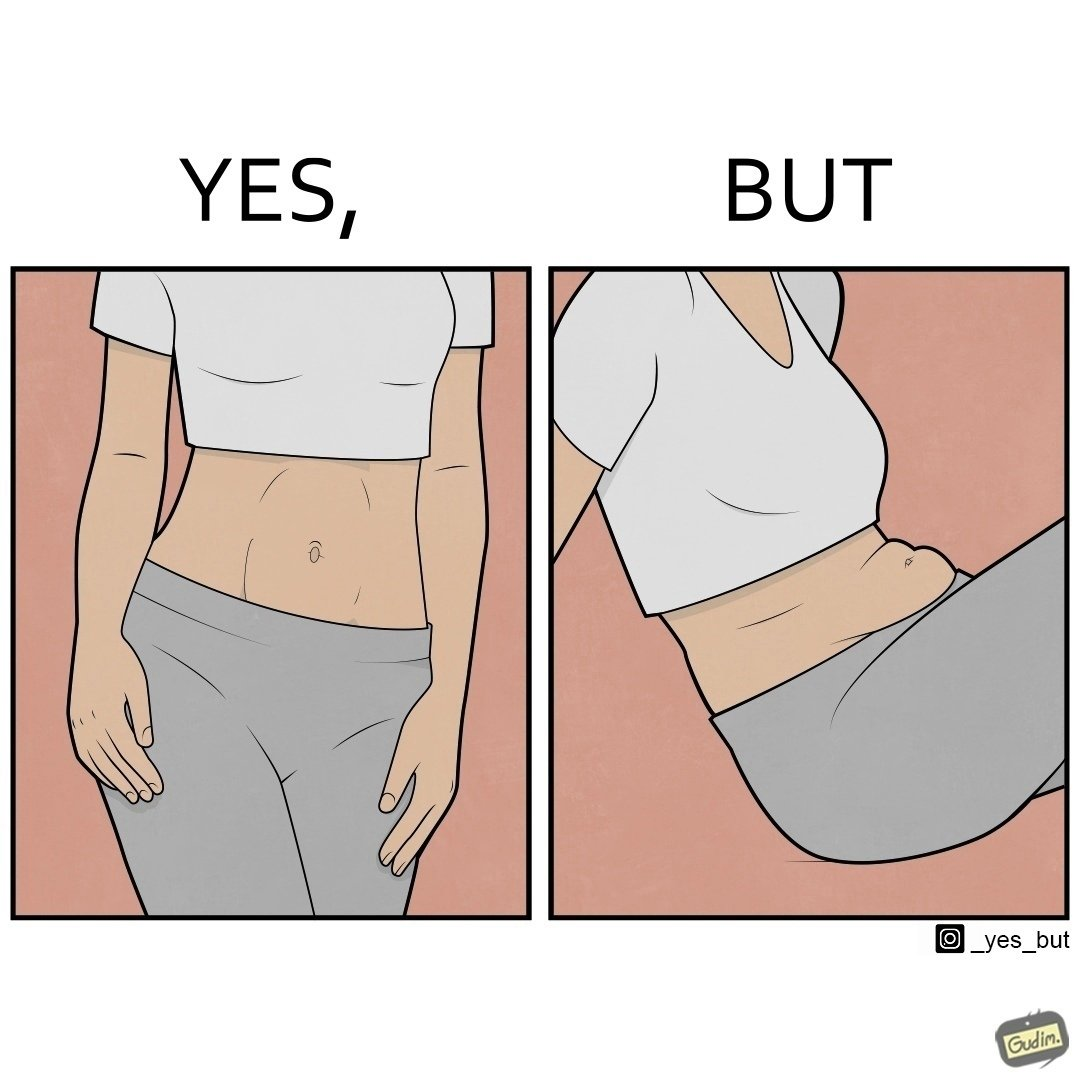What do you see in each half of this image? In the left part of the image: a slim woman In the right part of the image: An apparently chubby woman sitting 